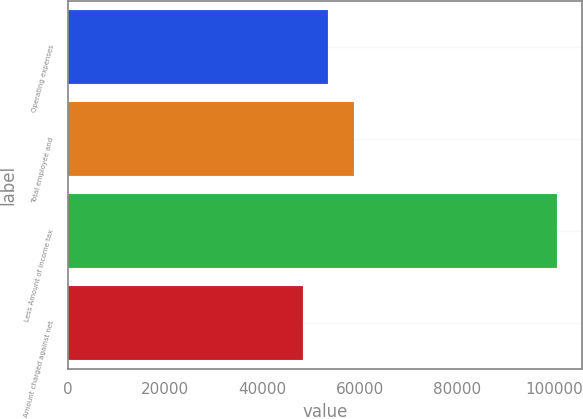Convert chart to OTSL. <chart><loc_0><loc_0><loc_500><loc_500><bar_chart><fcel>Operating expenses<fcel>Total employee and<fcel>Less Amount of income tax<fcel>Amount charged against net<nl><fcel>53581.2<fcel>58809.4<fcel>100635<fcel>48353<nl></chart> 